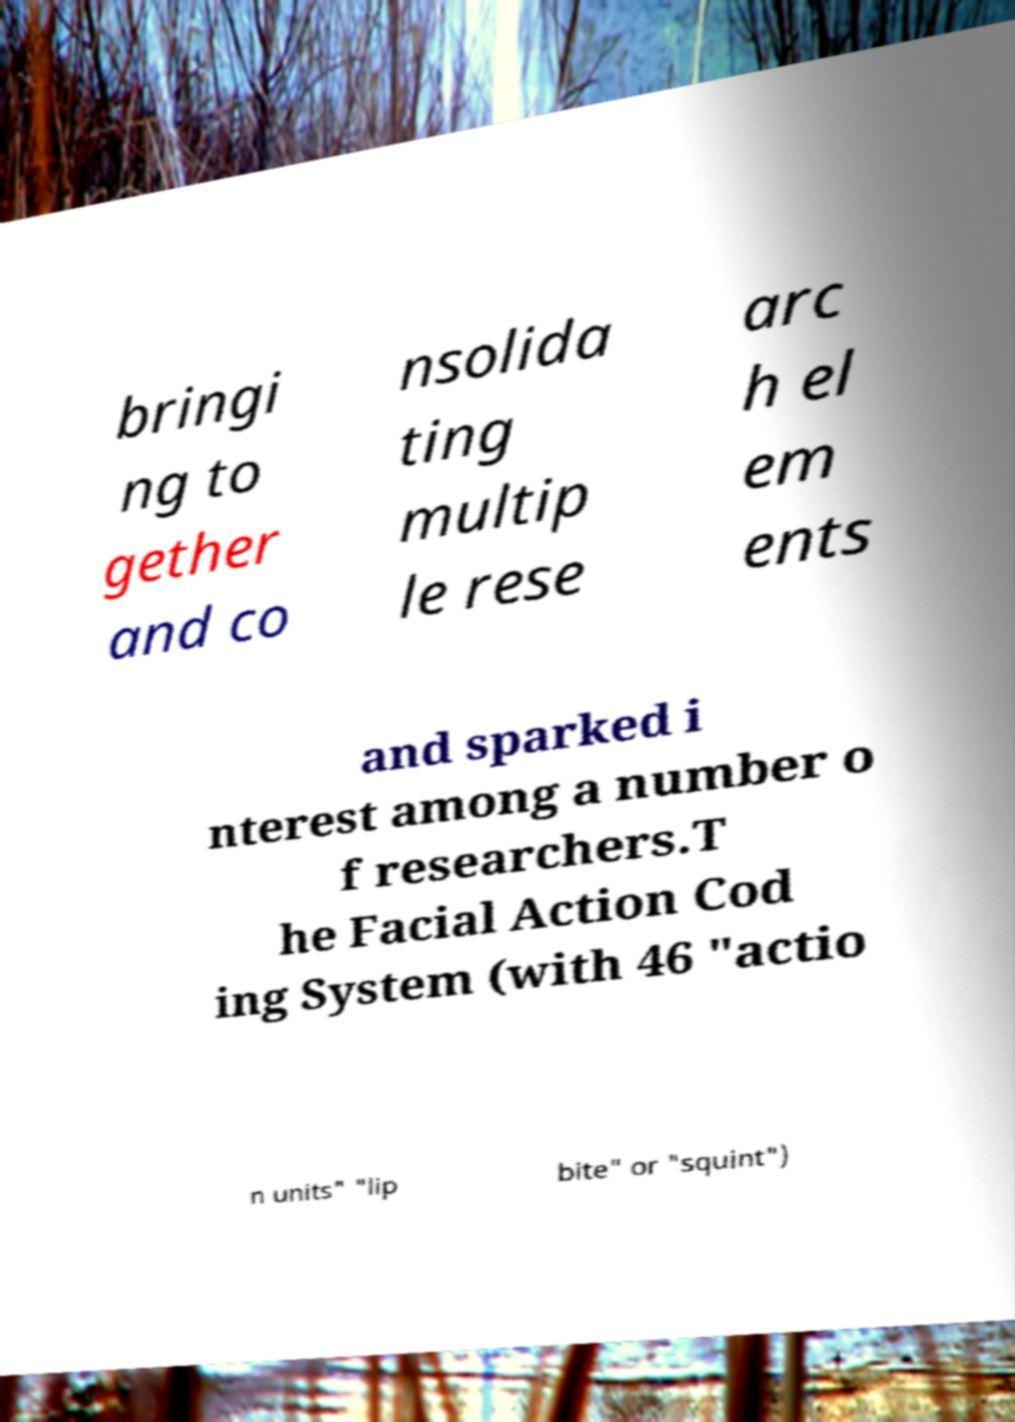Please read and relay the text visible in this image. What does it say? bringi ng to gether and co nsolida ting multip le rese arc h el em ents and sparked i nterest among a number o f researchers.T he Facial Action Cod ing System (with 46 "actio n units" "lip bite" or "squint") 